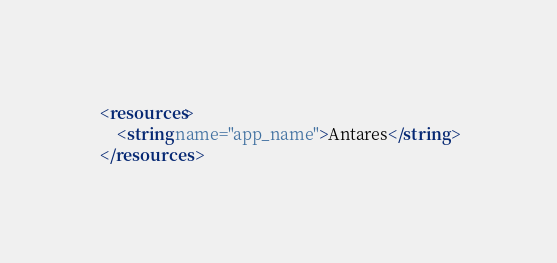<code> <loc_0><loc_0><loc_500><loc_500><_XML_><resources>
    <string name="app_name">Antares</string>
</resources>
</code> 